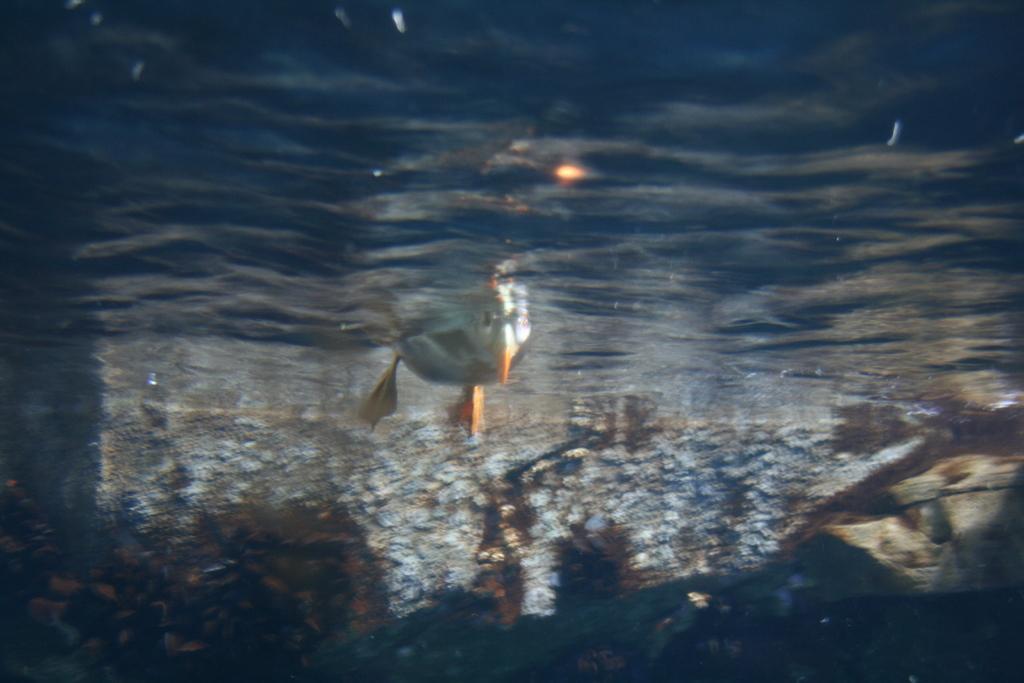Describe this image in one or two sentences. Inside the water we can see duck. Background it is blur. 